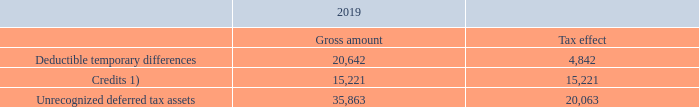Unrecognized deferred tax assets
Deferred tax assets have not been recognized in respect of the following items, given the volatile nature of the semi-conductor equipment industry. Therefore it is not probable that future taxable profit will be available to offset deductible temporary differences.
1 These credits regards R&D credits generated in the US, in the state of Arizona. However, ASMI does not recognize these credits stemming from prior years due to the fact that utilization of prior year credits is only possibly if and when the credits generated in the current year are fully utilized. Given the level of R&D activity in the US, the company does not expect it could fully utilize the credits generated in the current year and, hence, does not expect to benefit from the available credits generated in prior years.
Why are Deferred tax assets not recognized for the items in the table? Given the volatile nature of the semi-conductor equipment industry. What is the gross amount of  Deductible temporary differences ? 20,642. What is the  Tax effect of credits? 15,221. What is the gross Deductible temporary differences expressed as a percentage of gross Unrecognized deferred tax assets?
Answer scale should be: percent.  20,642 / 35,863 
Answer: 57.56. What is the tax effect of Deductible temporary differences expressed as a ratio of gross Deductible temporary differences? 4,842/20,642
Answer: 0.23. What is the difference in the gross amount of  Deductible temporary differences and Credits? 20,642-15,221
Answer: 5421. 